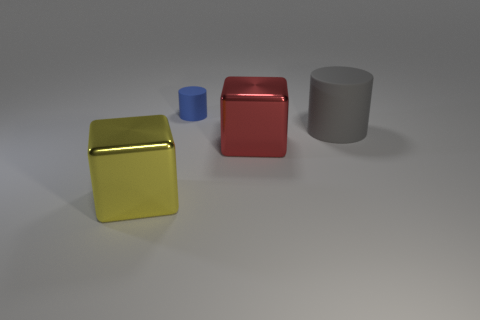What is the size of the cube right of the tiny rubber cylinder?
Offer a very short reply. Large. Are there any gray cylinders that are on the left side of the large shiny object that is on the right side of the blue cylinder?
Make the answer very short. No. Is the gray rubber object the same shape as the red metal object?
Offer a terse response. No. There is a object that is in front of the large gray matte cylinder and to the left of the large red shiny thing; what color is it?
Keep it short and to the point. Yellow. What number of large objects are gray rubber things or yellow objects?
Keep it short and to the point. 2. Is there any other thing that has the same color as the tiny rubber cylinder?
Your answer should be compact. No. There is a large block that is behind the large cube that is on the left side of the cube right of the big yellow object; what is it made of?
Keep it short and to the point. Metal. How many rubber objects are small yellow balls or large yellow things?
Provide a short and direct response. 0. How many red things are either metallic blocks or large metallic balls?
Provide a short and direct response. 1. Is the color of the large shiny thing that is on the right side of the yellow shiny cube the same as the small cylinder?
Offer a terse response. No. 